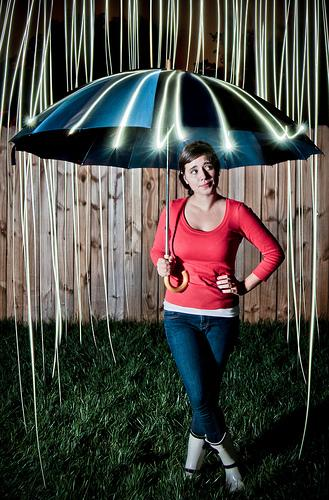Identify an unusual feature about the woman's shoes in the photo. The woman appears to be wearing white and black rubber boots with straps. Explain what the woman is doing with her hands in the image. The woman's right hand is on her hip, and her left hand is holding the handle of a large black umbrella. Provide a description of the main subject of the image, focusing on their attire. A young woman wearing jeans and a red top, capri length jeans, white and black rubber boots with straps, and holding a large black umbrella. Quantify the number of small patches of green grass in the image. There are ten small patches of green grass in the image. Describe the eye, nose, and head details in the image. The image includes the eye, nose, and head of a young woman, with specific coordinates for each feature. Explain the sentiment of the image by analyzing the subject's pose and attire. The woman is posing for the photo with a hand on her hip and an umbrella in hand, wearing casual attire and rubber boots, suggesting a relaxed and playful attitude. Describe the fence in the image. There is a wooden fence behind the woman. Are the woman's feet dry or wet? Her feet appear to be dry, protected by rubber boots. Analyze the ground in the image. There is green grass on the ground in the yard. What are the two distinct colors of the tops the woman is wearing? The woman is wearing one red top. 